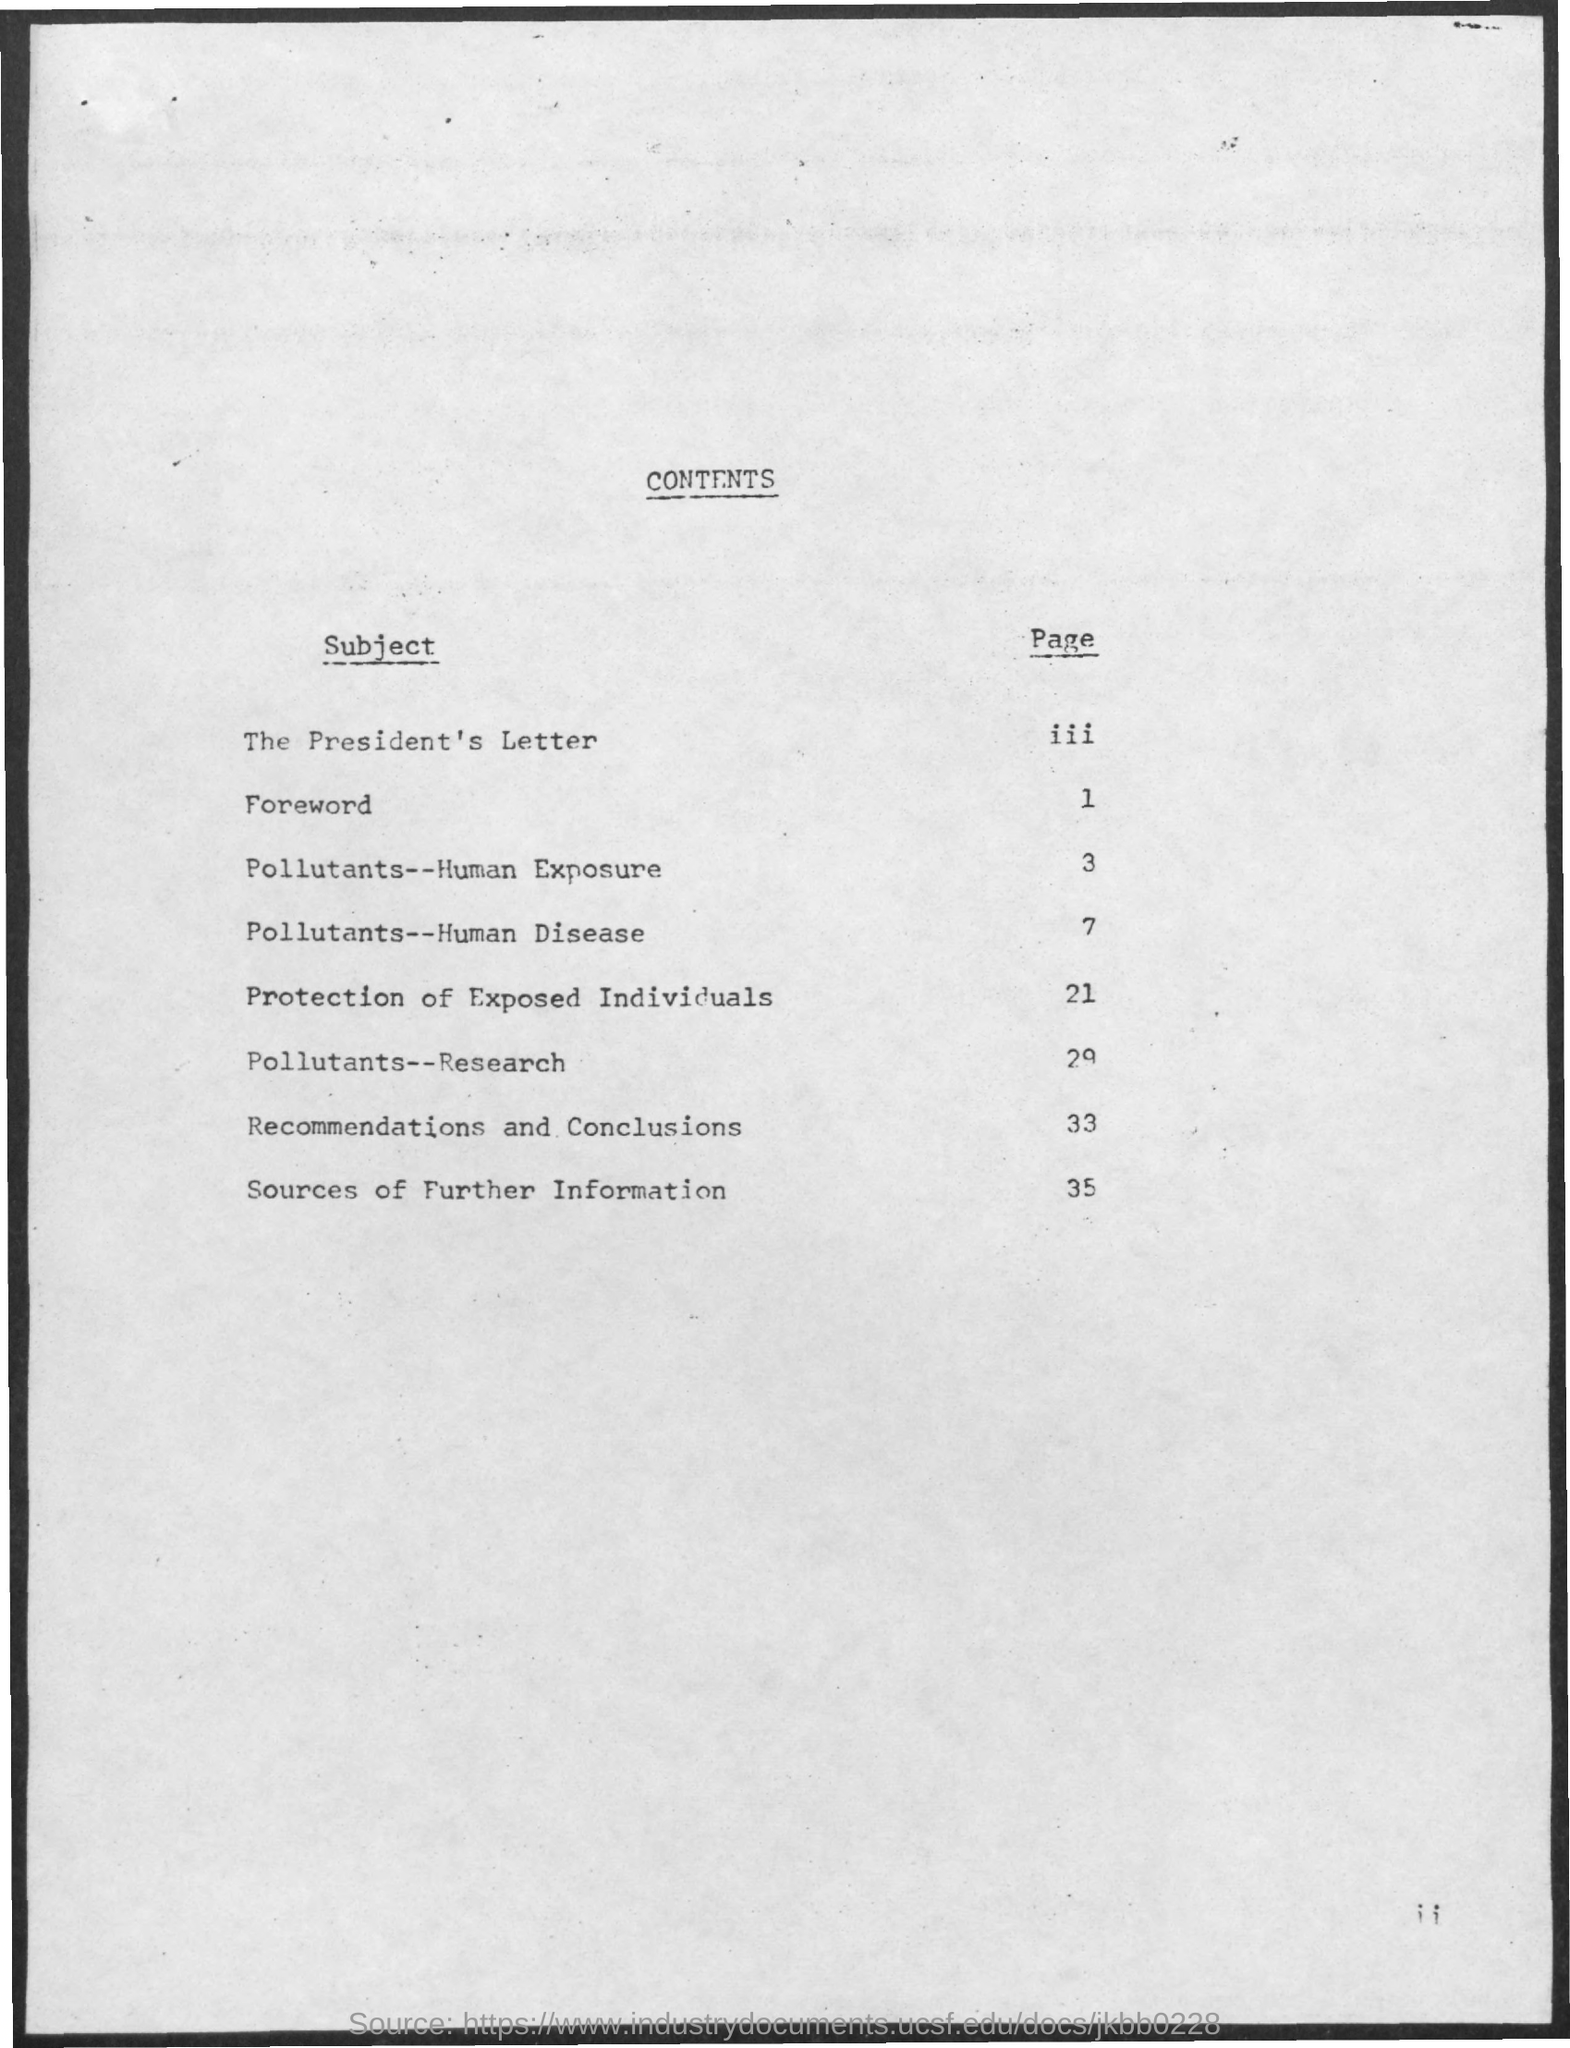What is the page no. for foreword subject ?
Ensure brevity in your answer.  1. What is the page no. for pollutants-- human exposure subject ?
Your answer should be compact. 3. What is the page no. for pollutants -- human disease subject ?
Provide a succinct answer. 7. What is the page no. for pollutants -- research subject ?
Make the answer very short. 29. What is the page no. for protection of exposed individuals subject ?
Keep it short and to the point. 21. What is the page no. for recommendations and conclusions ?
Provide a short and direct response. 33. What is the page no. for sources of further information ?
Your response must be concise. 35. 